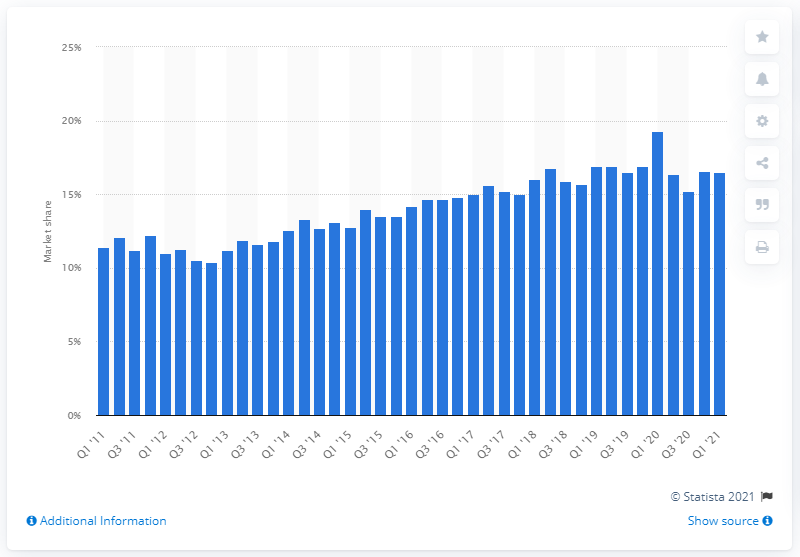Indicate a few pertinent items in this graphic. According to the given information, Dell's market share of PC shipments for the entire year of 2020 was approximately 15%. 